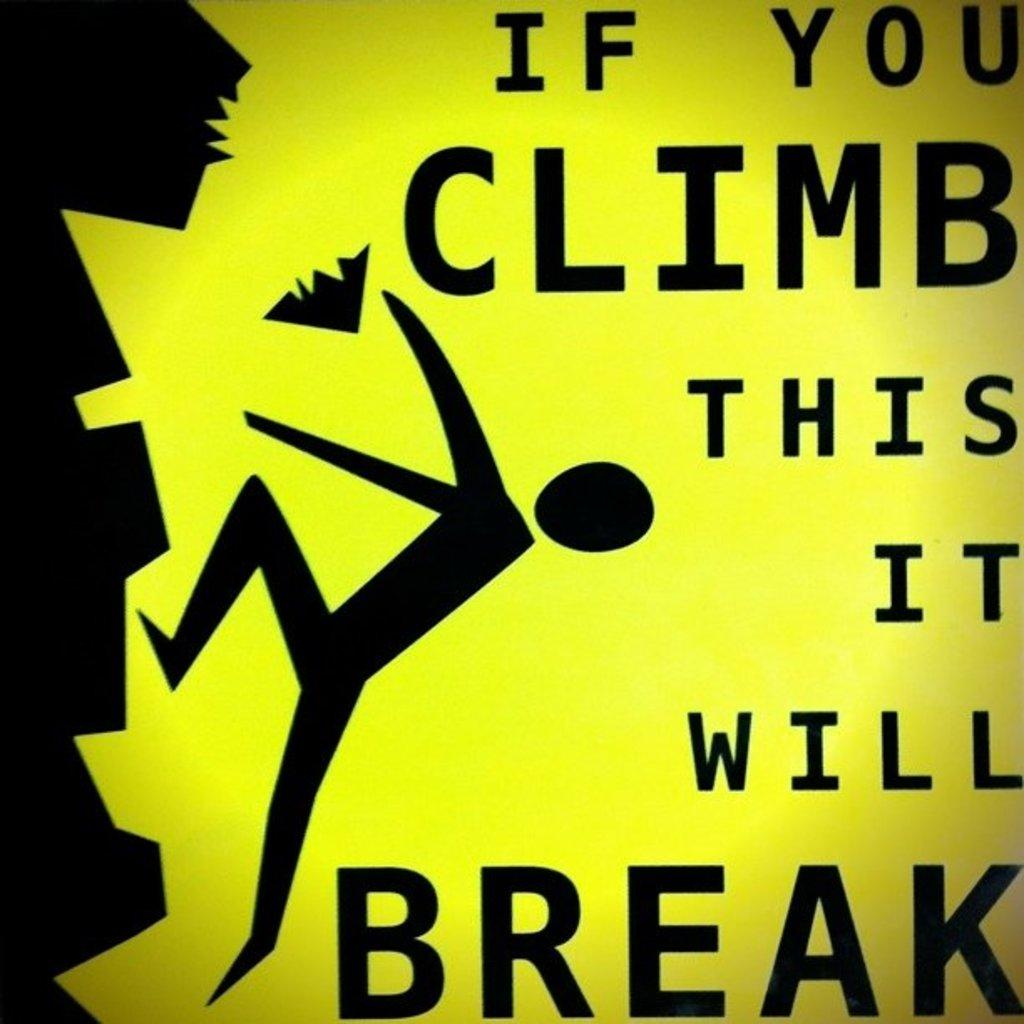Provide a one-sentence caption for the provided image. A yellow and black sign that is explaining the dangers of climbing on something. 